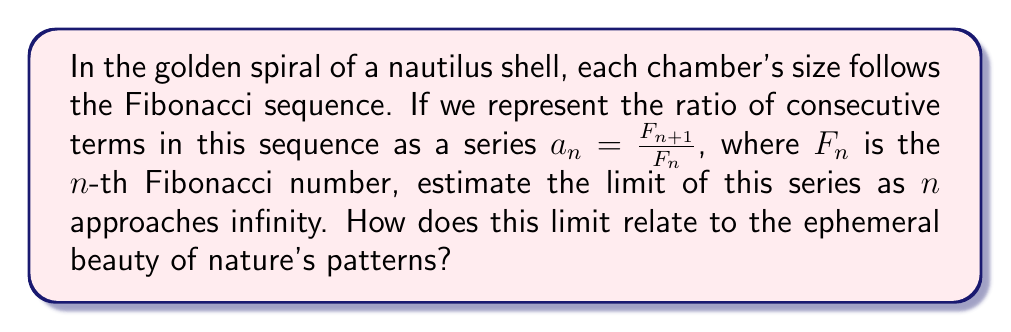What is the answer to this math problem? Let's approach this step-by-step:

1) First, recall the Fibonacci sequence: $1, 1, 2, 3, 5, 8, 13, 21, ...$

2) Our series $a_n = \frac{F_{n+1}}{F_n}$ looks like:

   $$a_1 = \frac{1}{1} = 1$$
   $$a_2 = \frac{2}{1} = 2$$
   $$a_3 = \frac{3}{2} = 1.5$$
   $$a_4 = \frac{5}{3} \approx 1.667$$
   $$a_5 = \frac{8}{5} = 1.6$$
   $$...$$

3) To estimate the limit, we can use the fact that the Fibonacci numbers have a closed form:

   $$F_n = \frac{\phi^n - (-\phi)^{-n}}{\sqrt{5}}$$

   where $\phi = \frac{1+\sqrt{5}}{2} \approx 1.618034$ is the golden ratio.

4) Now, let's consider the ratio of consecutive terms as $n$ approaches infinity:

   $$\lim_{n \to \infty} \frac{F_{n+1}}{F_n} = \lim_{n \to \infty} \frac{\frac{\phi^{n+1} - (-\phi)^{-(n+1)}}{\sqrt{5}}}{\frac{\phi^n - (-\phi)^{-n}}{\sqrt{5}}}$$

5) Simplify:

   $$= \lim_{n \to \infty} \frac{\phi^{n+1} - (-\phi)^{-(n+1)}}{\phi^n - (-\phi)^{-n}}$$

6) As $n$ approaches infinity, $(-\phi)^{-n}$ approaches 0 because $|-\phi^{-1}| < 1$. So:

   $$= \lim_{n \to \infty} \frac{\phi^{n+1}}{\phi^n} = \phi$$

Thus, the limit of the series approaches the golden ratio, $\phi \approx 1.618034$.

This limit reflects the eternal recurrence in nature's patterns, where each new growth builds upon the previous in a ratio that approaches perfection, yet remains forever just out of reach - a poetic metaphor for the beauty and impermanence of life itself.
Answer: $\phi \approx 1.618034$ (the golden ratio) 